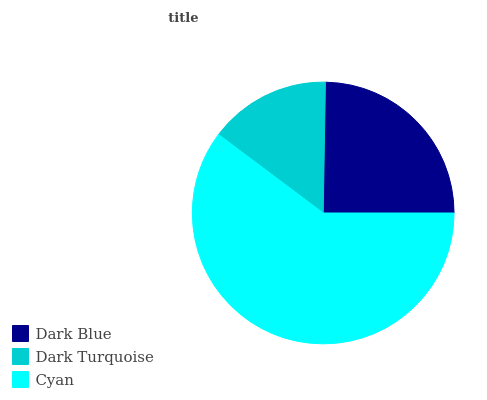Is Dark Turquoise the minimum?
Answer yes or no. Yes. Is Cyan the maximum?
Answer yes or no. Yes. Is Cyan the minimum?
Answer yes or no. No. Is Dark Turquoise the maximum?
Answer yes or no. No. Is Cyan greater than Dark Turquoise?
Answer yes or no. Yes. Is Dark Turquoise less than Cyan?
Answer yes or no. Yes. Is Dark Turquoise greater than Cyan?
Answer yes or no. No. Is Cyan less than Dark Turquoise?
Answer yes or no. No. Is Dark Blue the high median?
Answer yes or no. Yes. Is Dark Blue the low median?
Answer yes or no. Yes. Is Cyan the high median?
Answer yes or no. No. Is Cyan the low median?
Answer yes or no. No. 